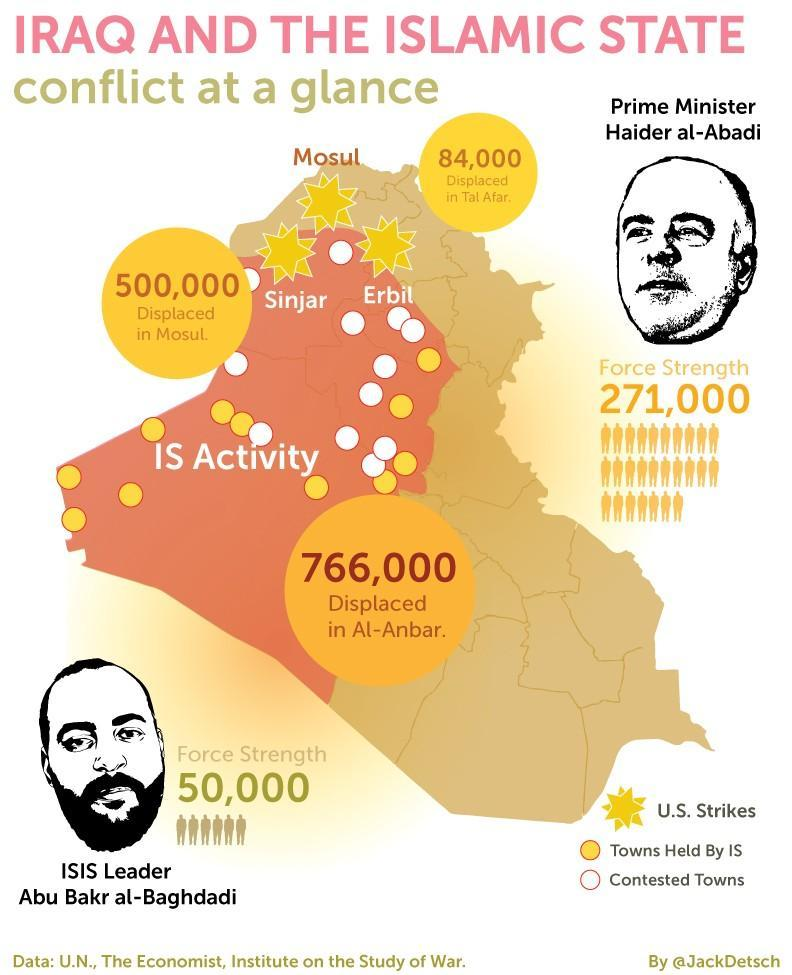How many contested towns are there?
Answer the question with a short phrase. 12 what is the total number of displaced in Al-Anbar and Mosul? 1266000 How many towns are held by ISIS? 11 what is the total number of displaced in Al-Anbar and Mosul? 850000 How many US strikes happened? 3 what is the total number of displaced in Al-Anbar, Tal Afar and Mosul? 1350000 who is the prime minister of Iraq? Haider Al-Abadi what is the total number of displaced in Tal Afar and Mosul? 584000 who has more force strength - ISIS or Iraq? Iraq what is the name of the person in figure given at the bottom? Abu Bakr al-Baghdadi 